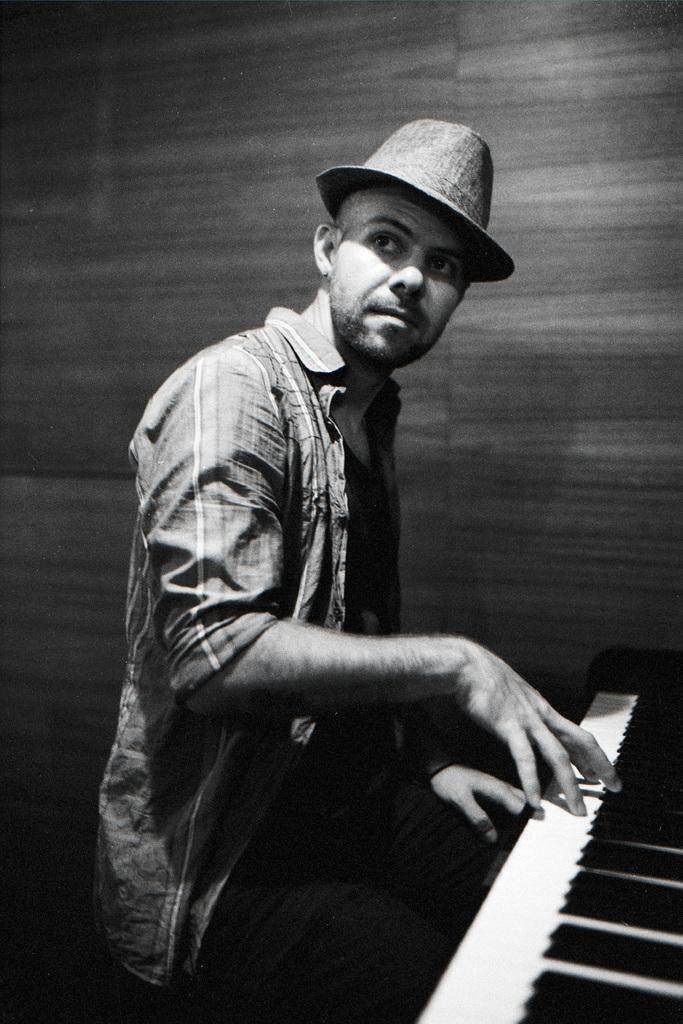What is the main subject of the image? The main subject of the image is a man. What is the man wearing on his head? The man is wearing a cap. What is the man doing in the image? The man has his hands on a piano. Where is the man's mother sitting in the image? There is no mention of the man's mother in the image, so we cannot determine her location. 